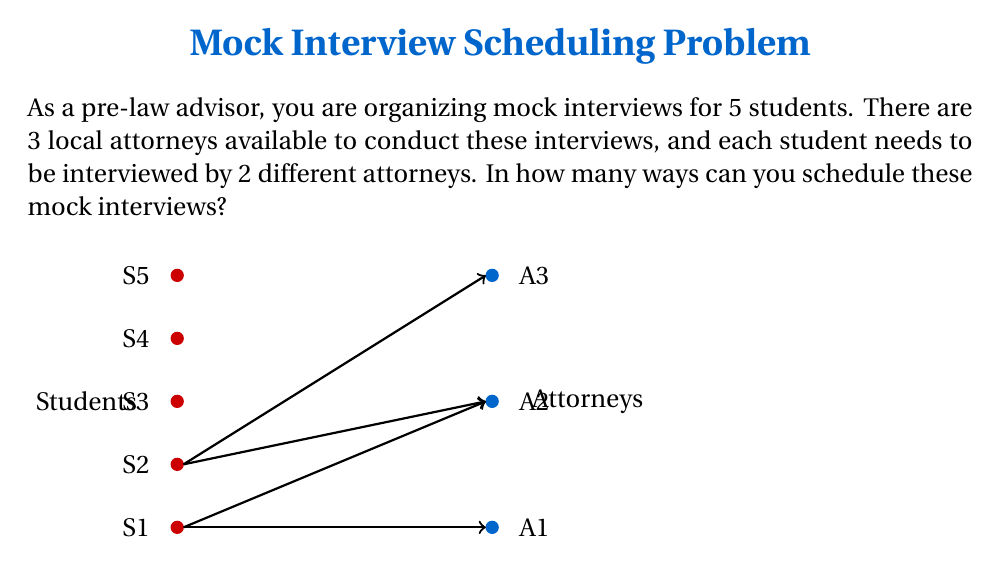Help me with this question. Let's approach this step-by-step:

1) First, we need to understand what we're counting. For each student, we need to choose 2 attorneys out of 3 available.

2) This is a combination problem. For each student, we're selecting 2 attorneys from 3, which can be represented as $\binom{3}{2}$.

3) The number of ways to choose 2 attorneys from 3 is:
   $$\binom{3}{2} = \frac{3!}{2!(3-2)!} = \frac{3 \cdot 2}{2 \cdot 1} = 3$$

4) Now, for each student, we have 3 ways to choose their 2 interviewers.

5) Since we have 5 students, and each student's choice is independent, we multiply these choices:
   $$3 \cdot 3 \cdot 3 \cdot 3 \cdot 3 = 3^5$$

6) Therefore, the total number of ways to schedule the mock interviews is $3^5$.

7) Calculating this:
   $$3^5 = 3 \cdot 3 \cdot 3 \cdot 3 \cdot 3 = 243$$

Thus, there are 243 different ways to schedule these mock interviews.
Answer: $243$ 